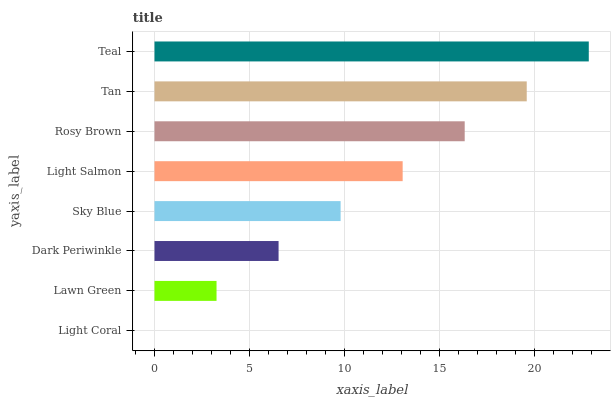Is Light Coral the minimum?
Answer yes or no. Yes. Is Teal the maximum?
Answer yes or no. Yes. Is Lawn Green the minimum?
Answer yes or no. No. Is Lawn Green the maximum?
Answer yes or no. No. Is Lawn Green greater than Light Coral?
Answer yes or no. Yes. Is Light Coral less than Lawn Green?
Answer yes or no. Yes. Is Light Coral greater than Lawn Green?
Answer yes or no. No. Is Lawn Green less than Light Coral?
Answer yes or no. No. Is Light Salmon the high median?
Answer yes or no. Yes. Is Sky Blue the low median?
Answer yes or no. Yes. Is Rosy Brown the high median?
Answer yes or no. No. Is Teal the low median?
Answer yes or no. No. 